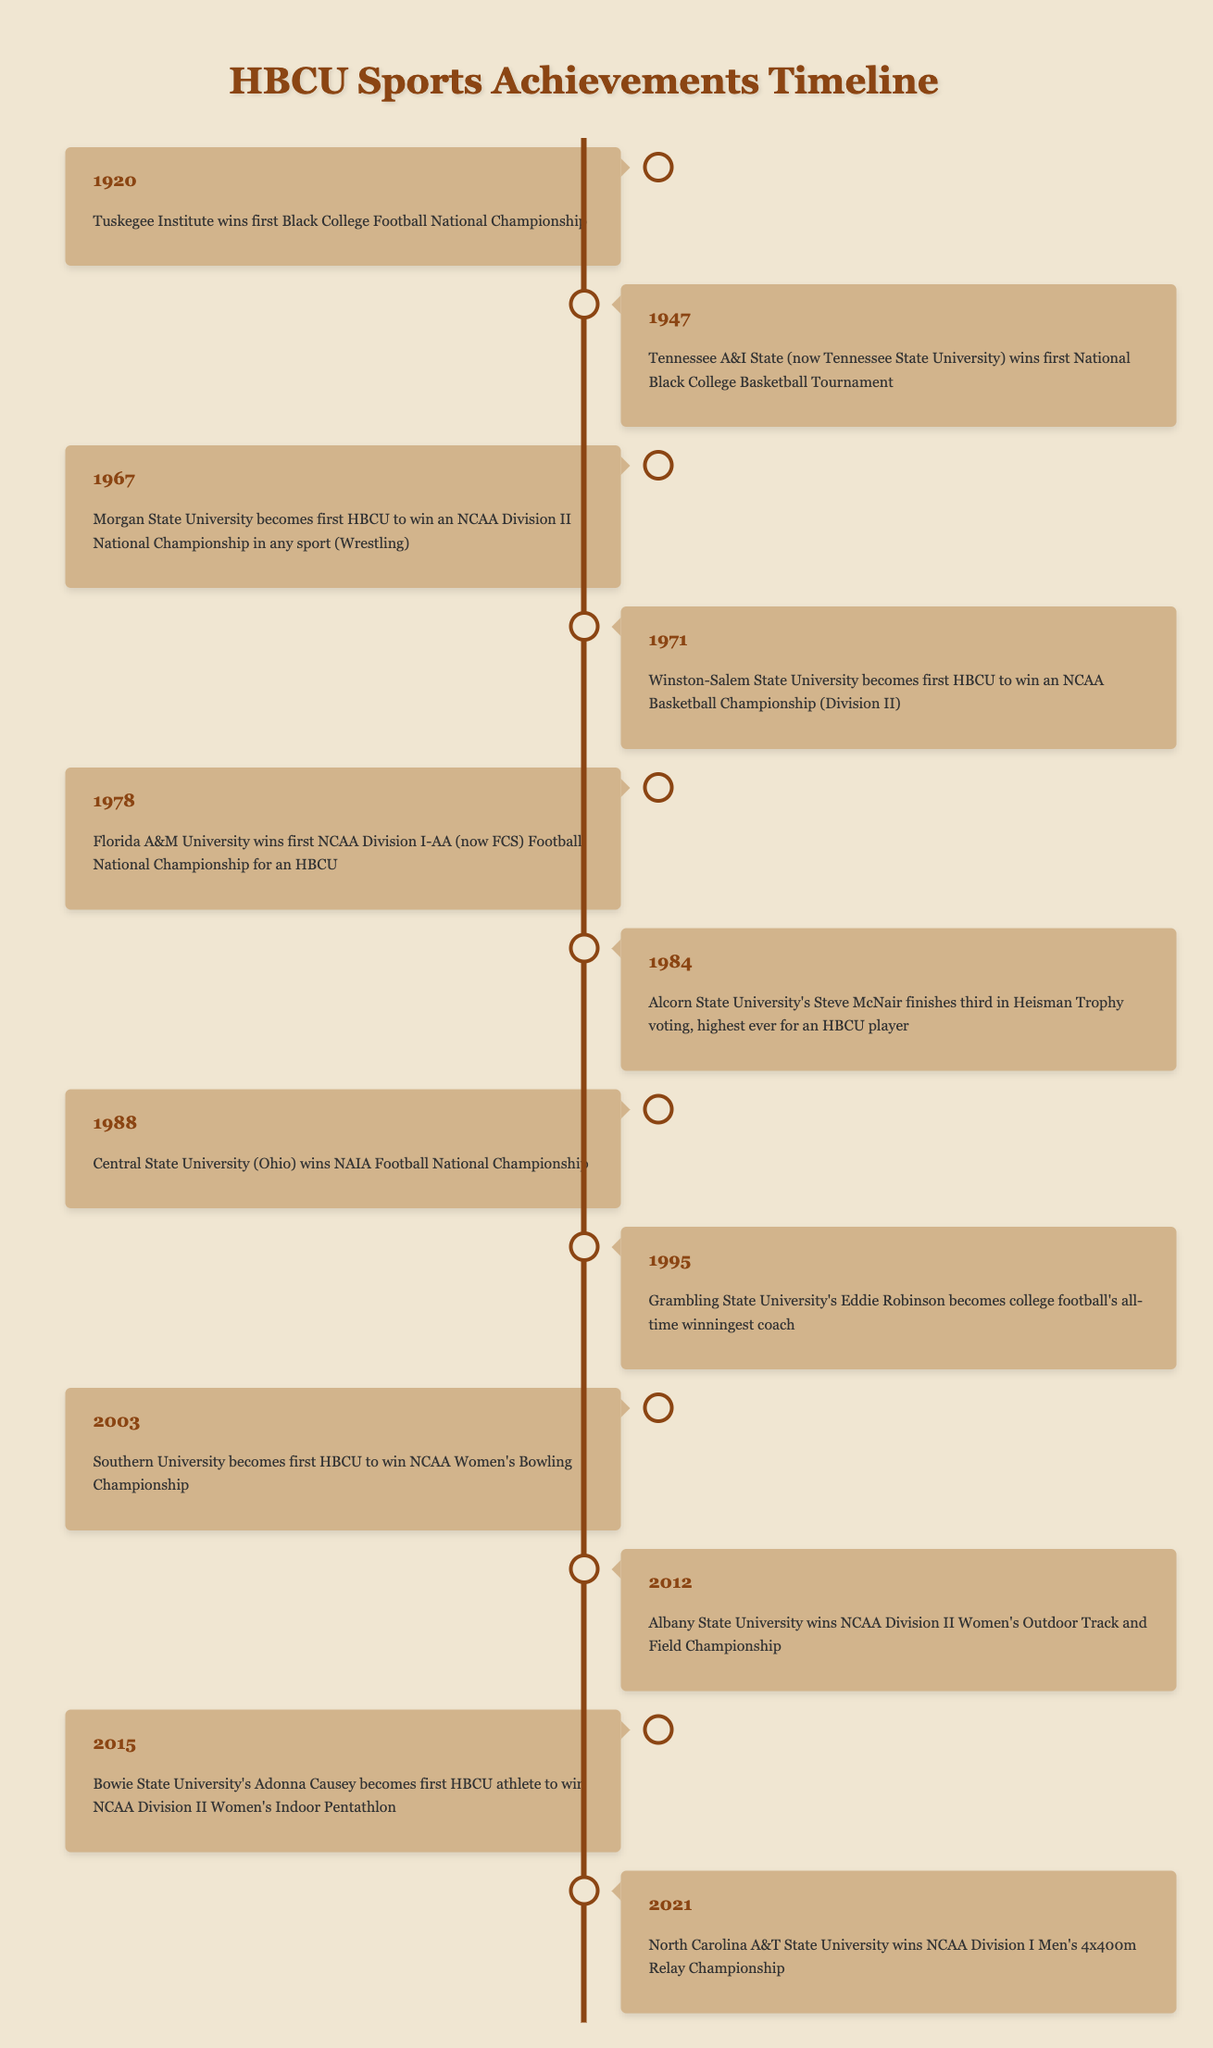What year did Tuskegee Institute win the first Black College Football National Championship? The table shows that Tuskegee Institute achieved this milestone in 1920.
Answer: 1920 Which HBCU first won an NCAA Basketball Championship and in what year? According to the table, Winston-Salem State University was the first HBCU to win an NCAA Basketball Championship in 1971.
Answer: Winston-Salem State University, 1971 How many years after Tuskegee's victory did Florida A&M University win the first NCAA Division I-AA Football Championship? Tuskegee won in 1920 and Florida A&M won in 1978. The difference is 1978 - 1920 = 58 years.
Answer: 58 years Did any HBCU win a national championship in women's bowling? Yes, Southern University won the NCAA Women's Bowling Championship as the first HBCU to do so in 2003.
Answer: Yes Which sport did Morgan State University win an NCAA Division II National Championship in, and in what year? The table states that Morgan State University won this championship in wrestling in 1967.
Answer: Wrestling, 1967 What is the most recent event in the timeline regarding HBCU sports achievements? The last event listed in the table is that North Carolina A&T State University won the NCAA Division I Men's 4x400m Relay Championship in 2021.
Answer: 2021 How many HBCUs won national championships between 1971 and 2003? The victories within that range are Winston-Salem State University (1971), Florida A&M University (1978), Central State University (1988), and Southern University (2003)—totaling 4 championships.
Answer: 4 Did Alcorn State University have a player finish in the top three for the Heisman Trophy? Yes, Alcorn State University's Steve McNair finished third in Heisman Trophy voting in 1984, which is confirmed in the table.
Answer: Yes Calculate the range of years covered by this timeline from the earliest to the latest event. The earliest event occurred in 1920 and the most recent in 2021, so the range is 2021 - 1920 = 101 years.
Answer: 101 years 